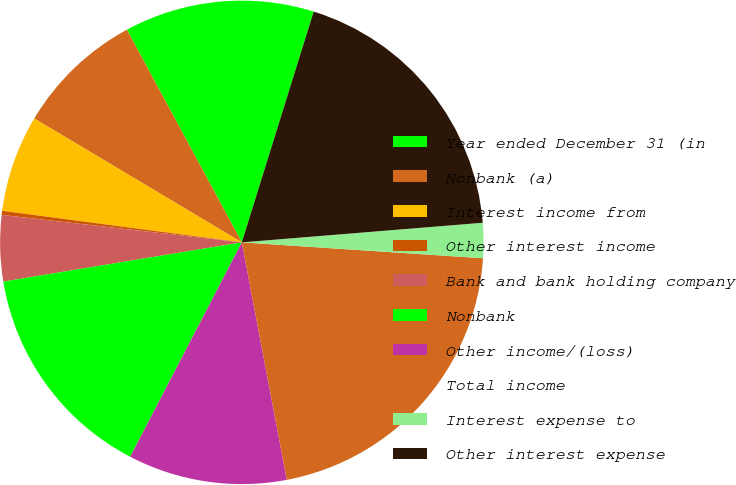Convert chart. <chart><loc_0><loc_0><loc_500><loc_500><pie_chart><fcel>Year ended December 31 (in<fcel>Nonbank (a)<fcel>Interest income from<fcel>Other interest income<fcel>Bank and bank holding company<fcel>Nonbank<fcel>Other income/(loss)<fcel>Total income<fcel>Interest expense to<fcel>Other interest expense<nl><fcel>12.69%<fcel>8.55%<fcel>6.48%<fcel>0.27%<fcel>4.41%<fcel>14.76%<fcel>10.62%<fcel>20.97%<fcel>2.34%<fcel>18.9%<nl></chart> 